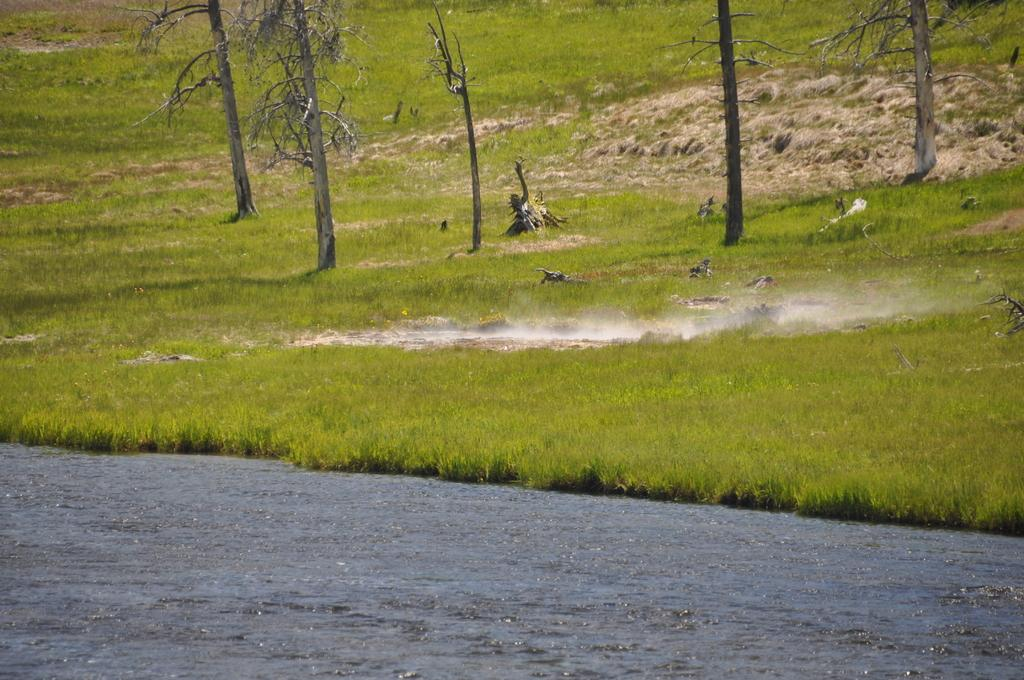What type of vegetation can be seen in the image? There are trees in the image. What is at the bottom of the image? There is grass at the bottom of the image. What natural element is visible in the image? There is water visible in the image. Is there any indication of a possible fire or smoke in the image? There might be smoke in the image. What grade is assigned to the key in the image? There is no key present in the image, so it cannot be assigned a grade. What type of print can be seen on the trees in the image? There is no print visible on the trees in the image. 